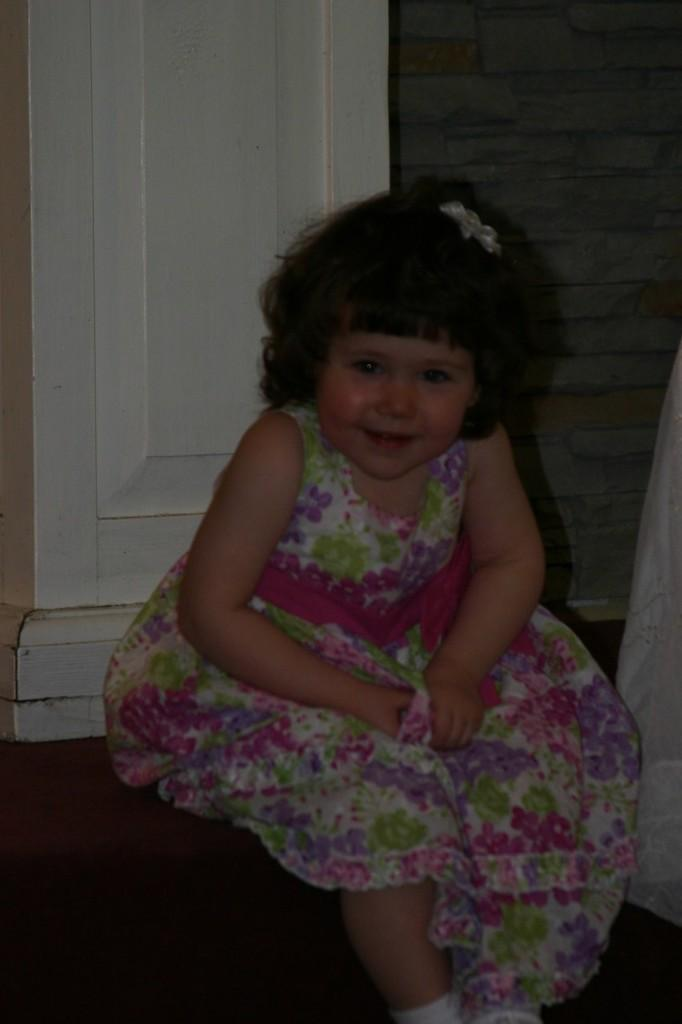Who is the main subject in the image? There is a girl in the image. What is the girl wearing? The girl is wearing a beautiful dress and shoes. What is the girl doing in the image? The girl is sitting on the stairs. What is located beside the girl? There is a door beside the girl. What can be seen on the right side of the image? There is a brick wall on the right side of the image. What type of hand can be seen playing a musical instrument in the image? There is no hand or musical instrument present in the image; it features a girl sitting on the stairs. What color is the brush used by the girl to paint the wall in the image? There is no brush or painting activity present in the image; the girl is simply sitting on the stairs. 